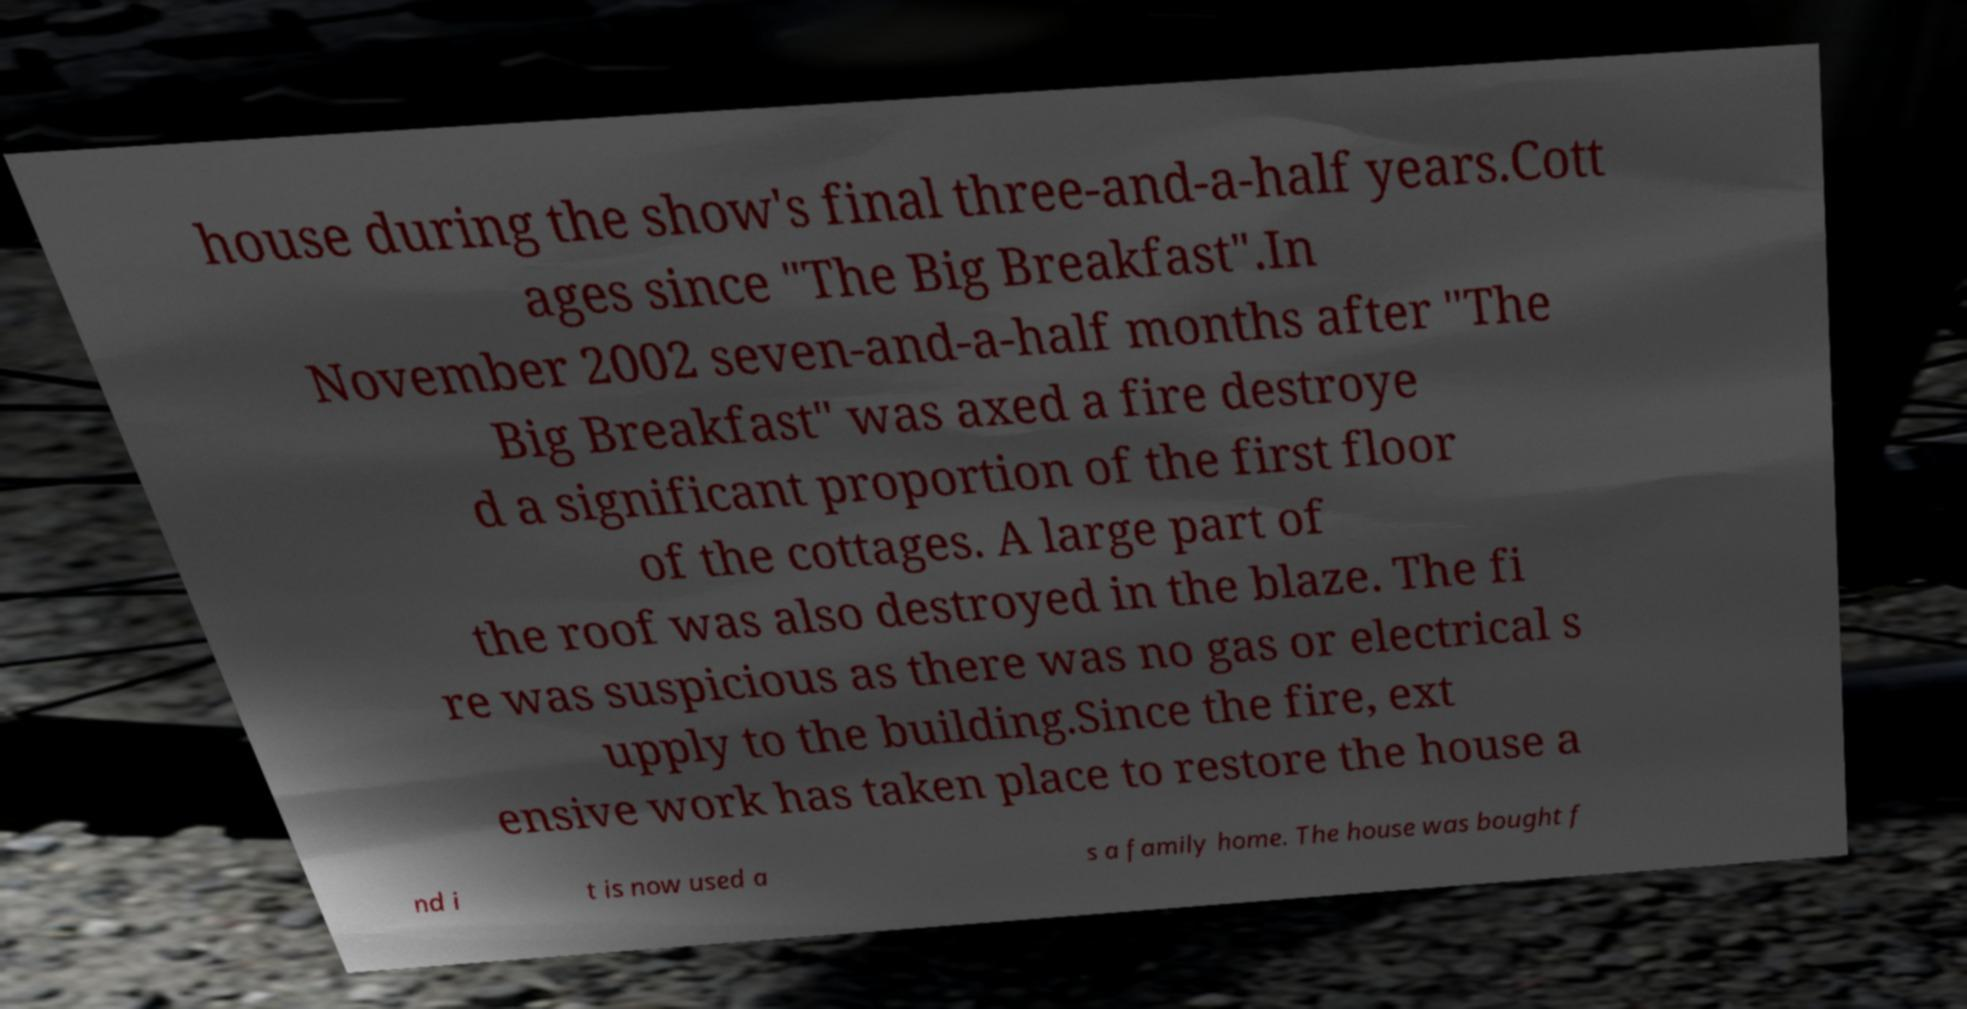Can you accurately transcribe the text from the provided image for me? house during the show's final three-and-a-half years.Cott ages since "The Big Breakfast".In November 2002 seven-and-a-half months after "The Big Breakfast" was axed a fire destroye d a significant proportion of the first floor of the cottages. A large part of the roof was also destroyed in the blaze. The fi re was suspicious as there was no gas or electrical s upply to the building.Since the fire, ext ensive work has taken place to restore the house a nd i t is now used a s a family home. The house was bought f 